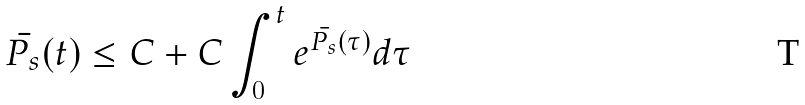Convert formula to latex. <formula><loc_0><loc_0><loc_500><loc_500>\bar { P _ { s } } ( t ) \leq C + C \int _ { 0 } ^ { t } e ^ { \bar { P _ { s } } ( \tau ) } d \tau</formula> 